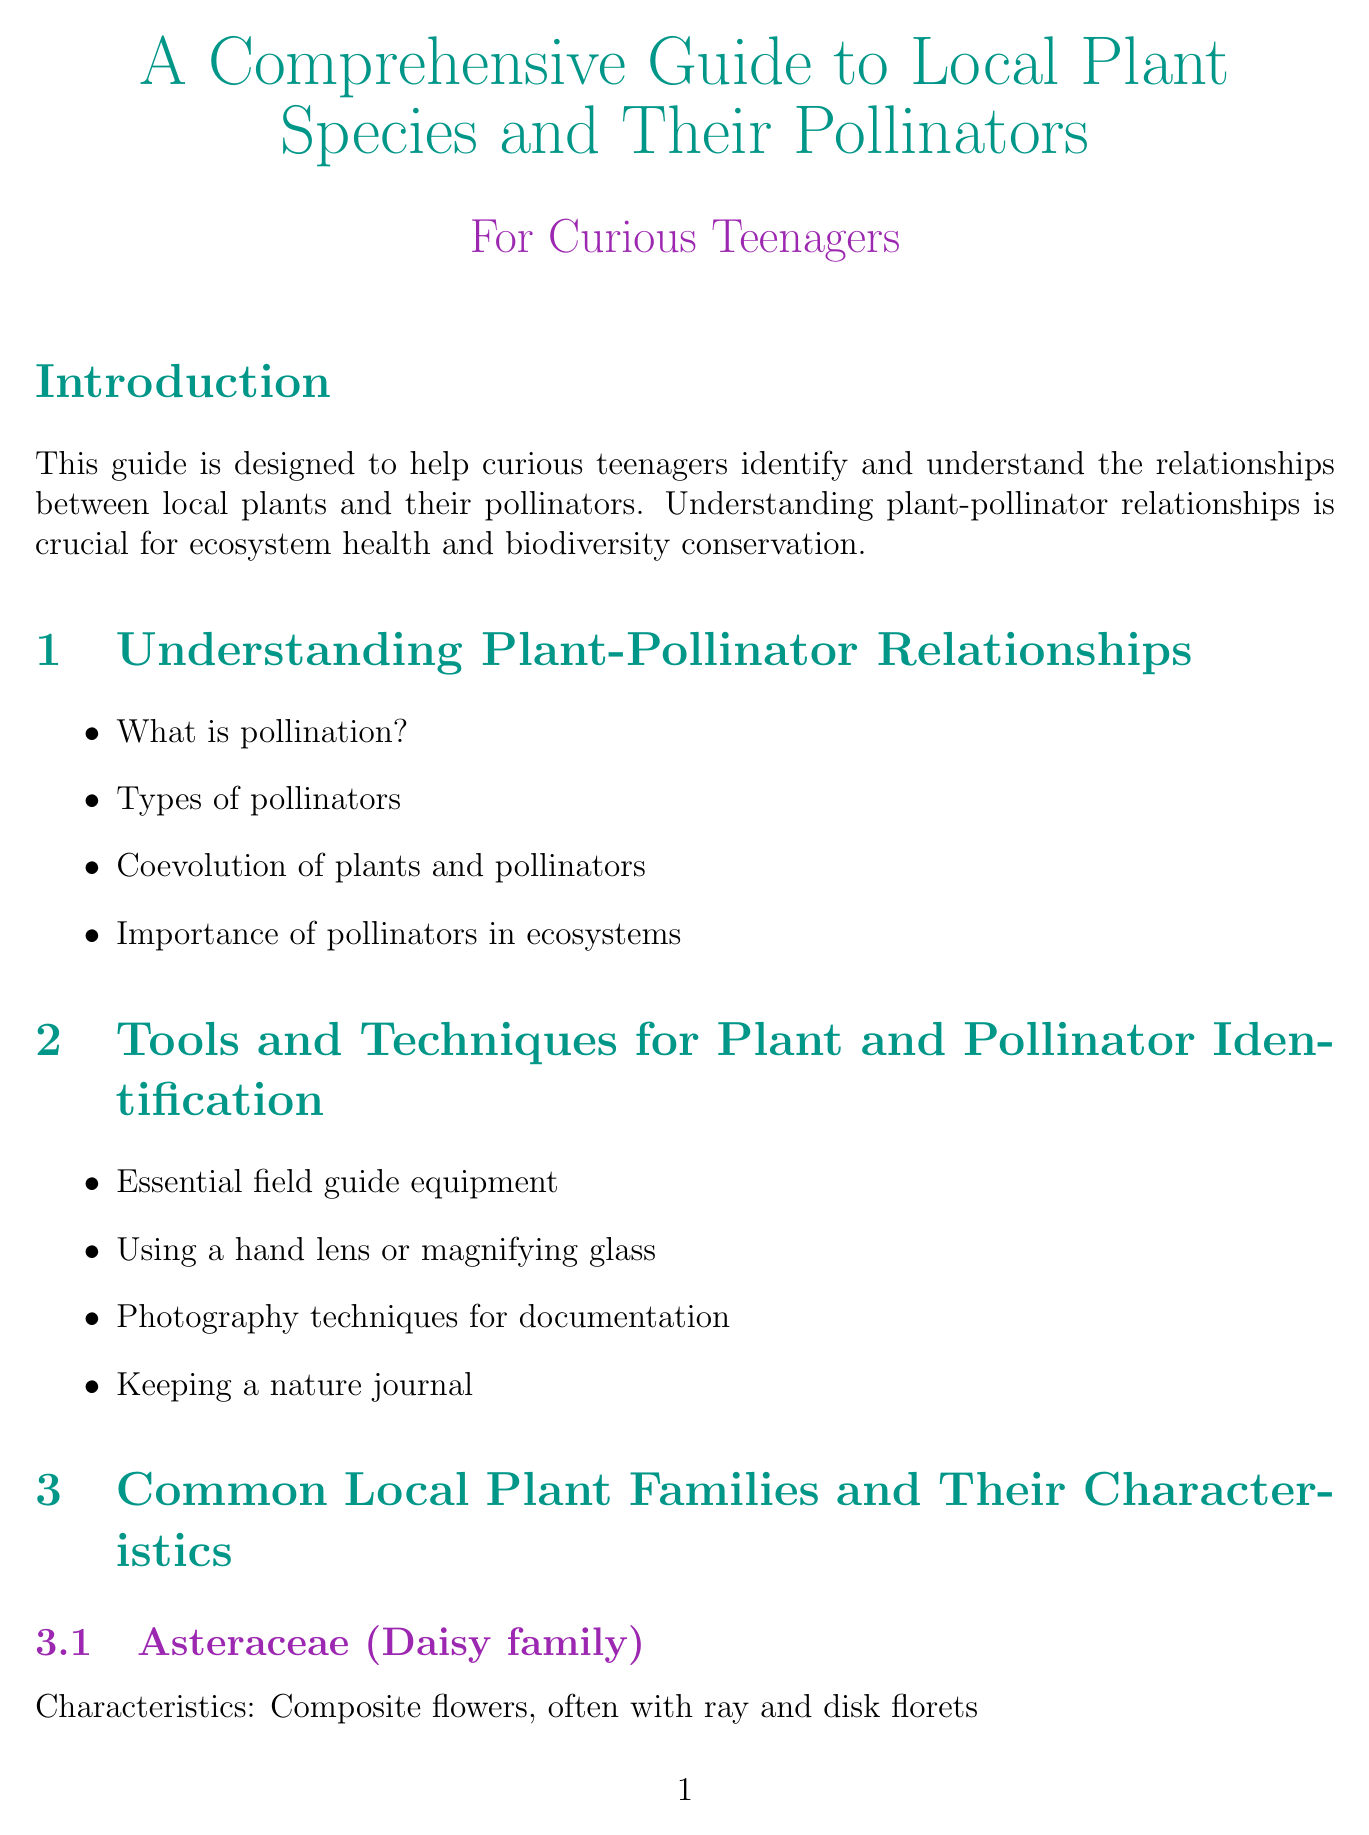What is the title of the manual? The title is stated in the document as a comprehensive guide to local plant species and their pollinators.
Answer: A Comprehensive Guide to Local Plant Species and Their Pollinators What family does the Black-eyed Susan belong to? The family is specified in the section detailing common local plant families and their characteristics.
Answer: Asteraceae (Daisy family) Name one type of pollinator listed in the document. The document provides a list of different pollinator groups, including various types.
Answer: Honey bees What is one essential field guide equipment mentioned? The section on tools and techniques for identification lists essential equipment for observing plants and pollinators.
Answer: Hand lens During which season are Mason bees active? The seasonal guide specifies which pollinators are active during each season.
Answer: Spring How many steps are there to create a pollinator-friendly garden? The number of steps is itemized in the section dedicated to creating a pollinator-friendly garden.
Answer: Six What is the website for the Bumble Bee Watch project? The project details include specific websites for citizen science initiatives listed in the document.
Answer: https://www.bumblebeewatch.org/ What is the definition of "Nectary"? The glossary section provides definitions for botanical terms used in the document.
Answer: A gland that secretes nectar in a flower 